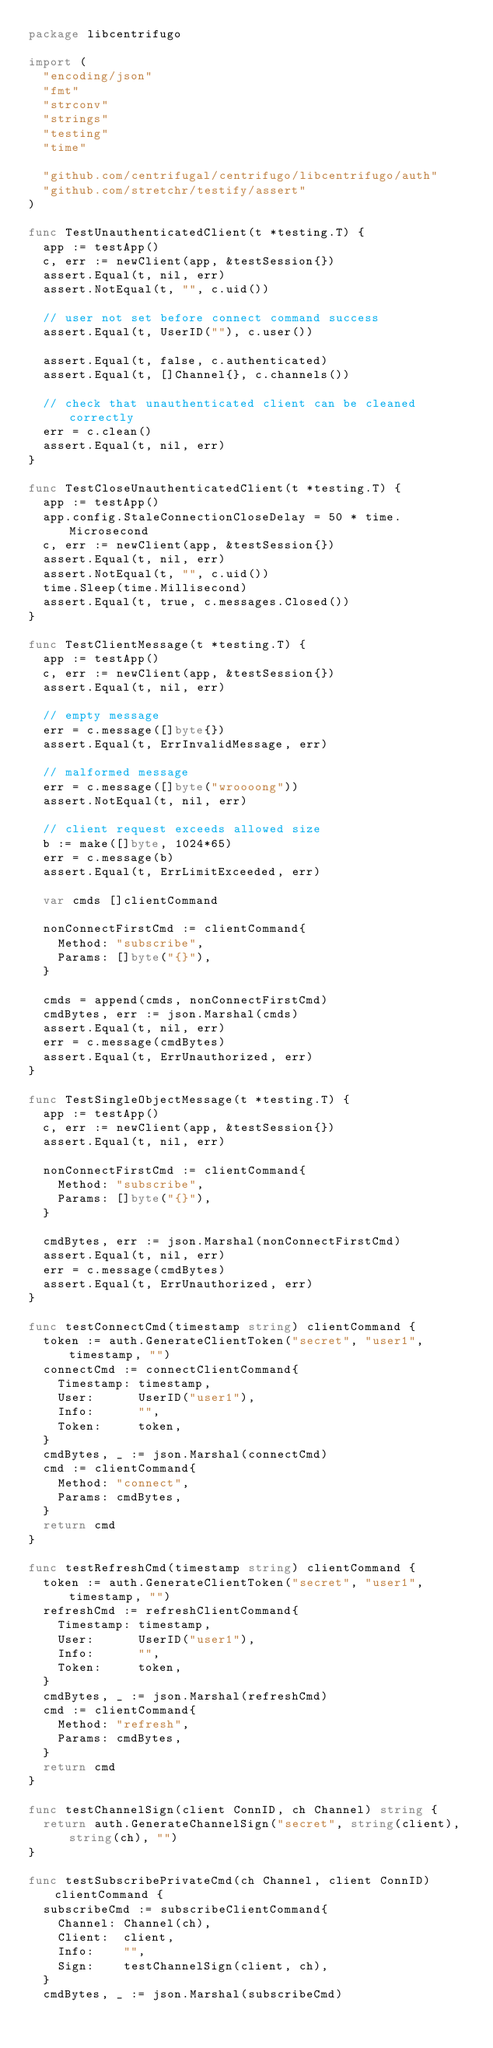Convert code to text. <code><loc_0><loc_0><loc_500><loc_500><_Go_>package libcentrifugo

import (
	"encoding/json"
	"fmt"
	"strconv"
	"strings"
	"testing"
	"time"

	"github.com/centrifugal/centrifugo/libcentrifugo/auth"
	"github.com/stretchr/testify/assert"
)

func TestUnauthenticatedClient(t *testing.T) {
	app := testApp()
	c, err := newClient(app, &testSession{})
	assert.Equal(t, nil, err)
	assert.NotEqual(t, "", c.uid())

	// user not set before connect command success
	assert.Equal(t, UserID(""), c.user())

	assert.Equal(t, false, c.authenticated)
	assert.Equal(t, []Channel{}, c.channels())

	// check that unauthenticated client can be cleaned correctly
	err = c.clean()
	assert.Equal(t, nil, err)
}

func TestCloseUnauthenticatedClient(t *testing.T) {
	app := testApp()
	app.config.StaleConnectionCloseDelay = 50 * time.Microsecond
	c, err := newClient(app, &testSession{})
	assert.Equal(t, nil, err)
	assert.NotEqual(t, "", c.uid())
	time.Sleep(time.Millisecond)
	assert.Equal(t, true, c.messages.Closed())
}

func TestClientMessage(t *testing.T) {
	app := testApp()
	c, err := newClient(app, &testSession{})
	assert.Equal(t, nil, err)

	// empty message
	err = c.message([]byte{})
	assert.Equal(t, ErrInvalidMessage, err)

	// malformed message
	err = c.message([]byte("wroooong"))
	assert.NotEqual(t, nil, err)

	// client request exceeds allowed size
	b := make([]byte, 1024*65)
	err = c.message(b)
	assert.Equal(t, ErrLimitExceeded, err)

	var cmds []clientCommand

	nonConnectFirstCmd := clientCommand{
		Method: "subscribe",
		Params: []byte("{}"),
	}

	cmds = append(cmds, nonConnectFirstCmd)
	cmdBytes, err := json.Marshal(cmds)
	assert.Equal(t, nil, err)
	err = c.message(cmdBytes)
	assert.Equal(t, ErrUnauthorized, err)
}

func TestSingleObjectMessage(t *testing.T) {
	app := testApp()
	c, err := newClient(app, &testSession{})
	assert.Equal(t, nil, err)

	nonConnectFirstCmd := clientCommand{
		Method: "subscribe",
		Params: []byte("{}"),
	}

	cmdBytes, err := json.Marshal(nonConnectFirstCmd)
	assert.Equal(t, nil, err)
	err = c.message(cmdBytes)
	assert.Equal(t, ErrUnauthorized, err)
}

func testConnectCmd(timestamp string) clientCommand {
	token := auth.GenerateClientToken("secret", "user1", timestamp, "")
	connectCmd := connectClientCommand{
		Timestamp: timestamp,
		User:      UserID("user1"),
		Info:      "",
		Token:     token,
	}
	cmdBytes, _ := json.Marshal(connectCmd)
	cmd := clientCommand{
		Method: "connect",
		Params: cmdBytes,
	}
	return cmd
}

func testRefreshCmd(timestamp string) clientCommand {
	token := auth.GenerateClientToken("secret", "user1", timestamp, "")
	refreshCmd := refreshClientCommand{
		Timestamp: timestamp,
		User:      UserID("user1"),
		Info:      "",
		Token:     token,
	}
	cmdBytes, _ := json.Marshal(refreshCmd)
	cmd := clientCommand{
		Method: "refresh",
		Params: cmdBytes,
	}
	return cmd
}

func testChannelSign(client ConnID, ch Channel) string {
	return auth.GenerateChannelSign("secret", string(client), string(ch), "")
}

func testSubscribePrivateCmd(ch Channel, client ConnID) clientCommand {
	subscribeCmd := subscribeClientCommand{
		Channel: Channel(ch),
		Client:  client,
		Info:    "",
		Sign:    testChannelSign(client, ch),
	}
	cmdBytes, _ := json.Marshal(subscribeCmd)</code> 